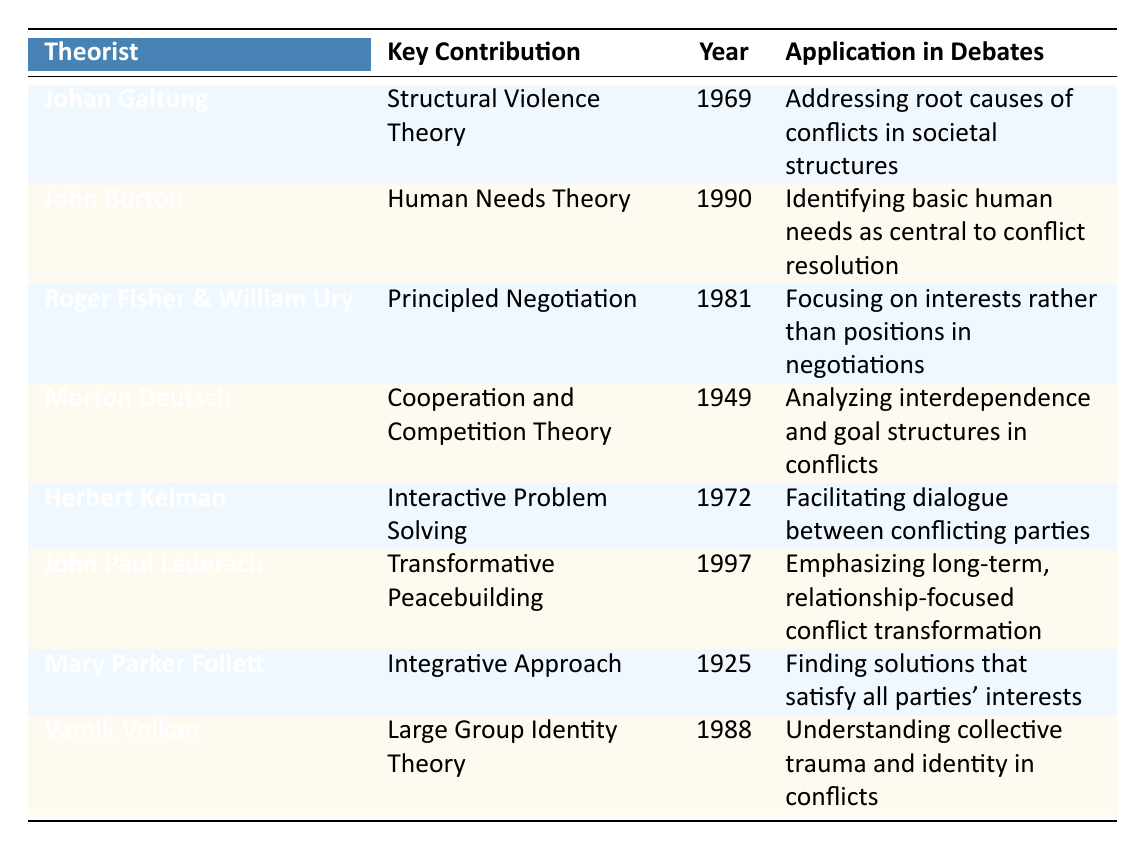What is the key contribution of Johan Galtung? By looking at the "Key Contribution" column for Johan Galtung, we find the entry: "Structural Violence Theory".
Answer: Structural Violence Theory Which theorist contributed the "Human Needs Theory"? The table displays the entry under the "Theorist" column named "John Burton", who is associated with the "Human Needs Theory" contribution.
Answer: John Burton What year did Roger Fisher and William Ury propose their key contribution? By checking the "Year" column associated with Roger Fisher & William Ury in the table, we see that their contribution was made in the year 1981.
Answer: 1981 True or False: Vamik Volkan's key contribution is known as Large Group Identity Theory. The table states that Vamik Volkan is indeed associated with "Large Group Identity Theory", which confirms the fact is true.
Answer: True What is the application in debates for Mary Parker Follett's contribution? Referring to the "Application in Debates" column, we can see that her contribution addresses "Finding solutions that satisfy all parties' interests".
Answer: Finding solutions that satisfy all parties' interests Which theorists' contributions emphasize dialogue between conflicting parties? Looking at the table, "Herbert Kelman" is the theorist associated with "Interactive Problem Solving", which emphasizes dialogue between conflicting parties.
Answer: Herbert Kelman If we take the earliest and latest contributions from the table, what year difference do they span? The earliest contribution is by Mary Parker Follett in 1925, and the latest is by John Paul Lederach in 1997. The difference between 1997 and 1925 is 72 years.
Answer: 72 years How many theorists listed in the table contributed after 1970? By examining the years listed in the table, we can see that John Burton (1990), Roger Fisher & William Ury (1981), Herbert Kelman (1972), John Paul Lederach (1997), and Vamik Volkan (1988) all contributed after 1970. This gives us a total of 5 theorists.
Answer: 5 Which theorist's approach focuses on relationship transformation rather than immediate conflict resolution? The key contribution of John Paul Lederach is "Transformative Peacebuilding", which emphasizes long-term, relationship-focused transformation instead of immediate fixes to conflicts.
Answer: John Paul Lederach 